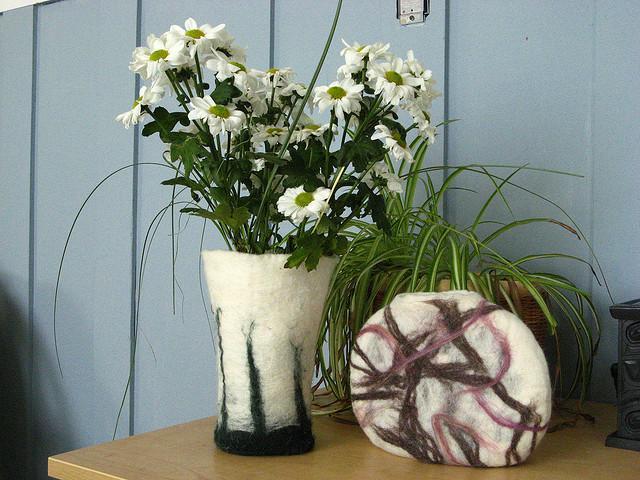How many cars are parked in this picture?
Give a very brief answer. 0. 